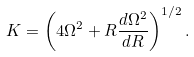Convert formula to latex. <formula><loc_0><loc_0><loc_500><loc_500>K = \left ( 4 \Omega ^ { 2 } + R \frac { d \Omega ^ { 2 } } { d R } \right ) ^ { 1 / 2 } .</formula> 